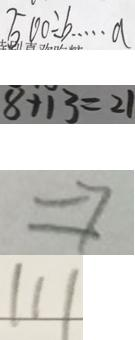<formula> <loc_0><loc_0><loc_500><loc_500>5 0 0 \div b \cdots a 
 8 + 1 3 = 2 1 
 \Rightarrow 
 1 1 1</formula> 